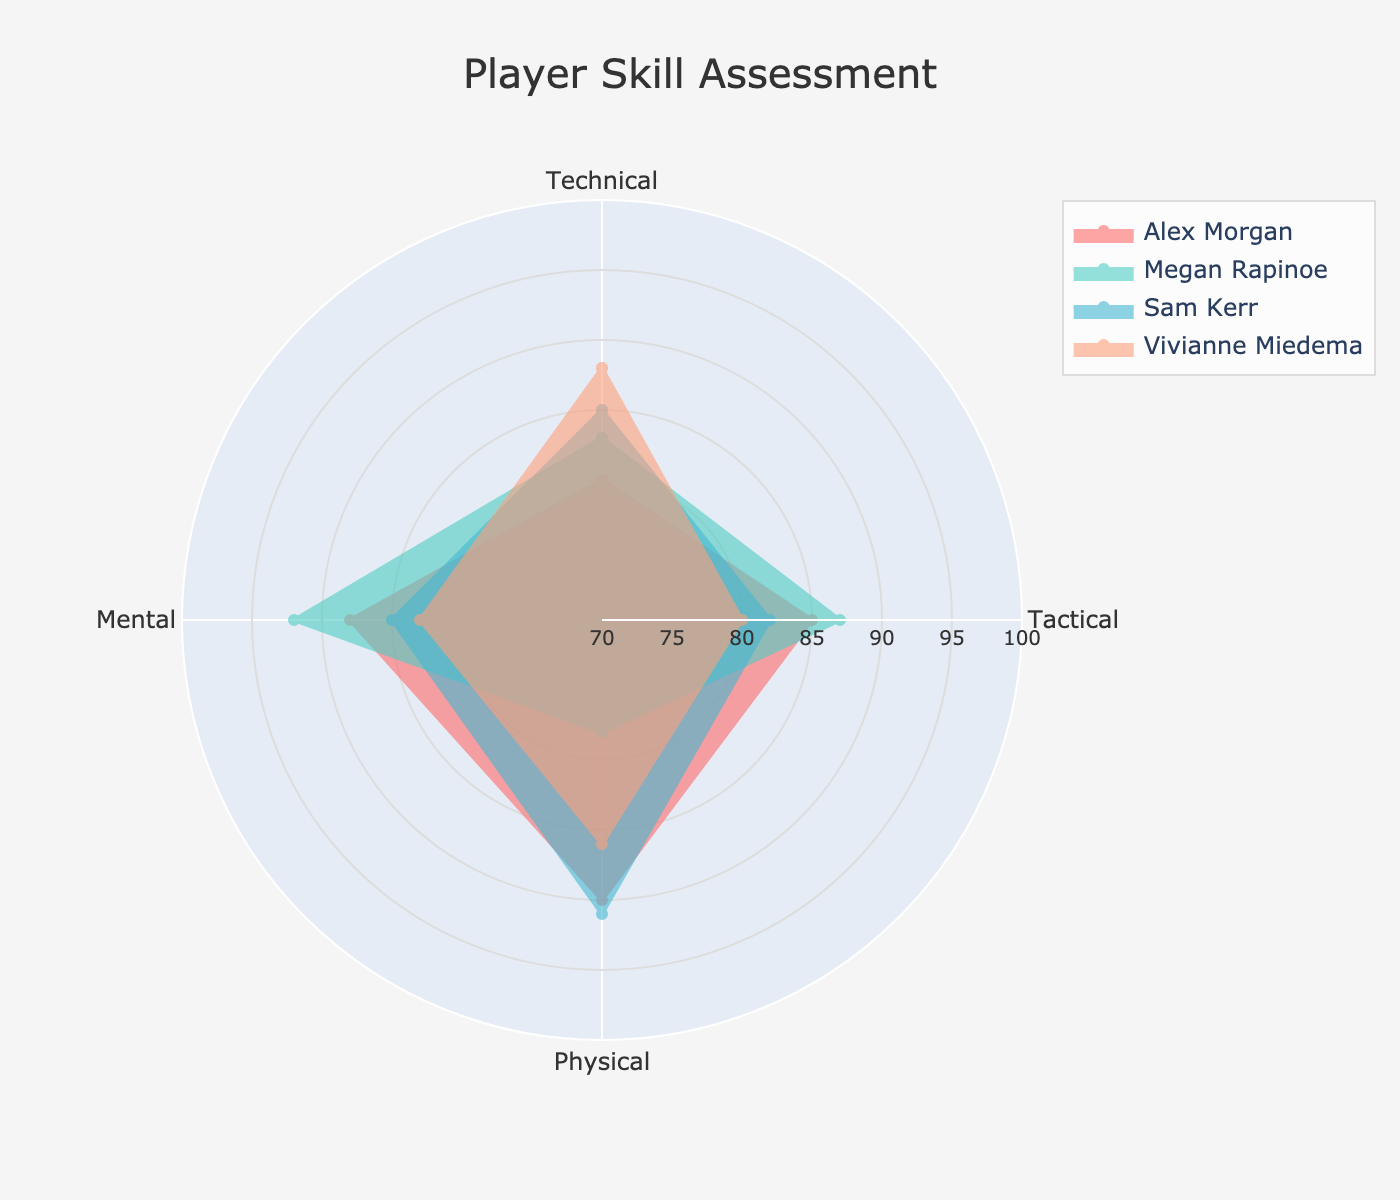What's the title of the radar chart? Look at the top of the chart where the title is usually placed. The title should describe the content of the radar chart.
Answer: Player Skill Assessment Which player has the highest Technical score? Compare the Technical scores of all players listed around the radar chart's axes. The player associated with the highest value is the one with the highest Technical score.
Answer: Vivianne Miedema Who has the lowest Physical score? Inspect each player's Physical score on the radar chart. The lowest score will be the one that's closest to the center.
Answer: Megan Rapinoe Which category does Sam Kerr excel in the most? Look at the radar chart's axes corresponding to Sam Kerr's scores. Identify the highest score among Technical, Tactical, Physical, and Mental categories.
Answer: Physical Average Mental score of all players? Sum up all the Mental scores for each player (88 + 92 + 85 + 83 = 348). Then, divide by the number of players (4). 348 / 4 = 87.
Answer: 87 Which player has the most balanced skill set across categories? A balanced skill set would mean similar lengths of the axes radiating from the center for one player. Compare the shapes of the radar plots for all players to see which one is closest to a round shape.
Answer: Vivianne Miedema Who has the highest combined total score of all categories? Sum the scores for Technical, Tactical, Physical, and Mental for each player. Alex Morgan: 343, Megan Rapinoe: 340, Sam Kerr: 343, Vivianne Miedema: 337. Compare totals to find the highest.
Answer: Alex Morgan and Sam Kerr Which player has the most disparity between their highest and lowest scores? Calculate the difference between the highest and lowest scores for each player. Compare the differences to find the largest one.
Answer: Megan Rapinoe If the total score range was adjusted to 0-100, which player would have the highest average score across all categories? Calculate the average score for each player if the scores are normalized (though they're already in 0-100, we take raw averages here). For each player, sum the scores and divide by 4. Compare the averages: Alex Morgan (85.75), Megan Rapinoe (85), Sam Kerr (85.75), Vivianne Miedema (84.25). The ones with the highest average are Alex Morgan and Sam Kerr.
Answer: Alex Morgan and Sam Kerr Given the same total score, do Alex Morgan and Sam Kerr have the same proficiency across each category? Examine and compare the detailed scores in each category for Alex Morgan and Sam Kerr. Alex Morgan: Technical (80), Tactical (85), Physical (90), Mental (88). Sam Kerr: Technical (85), Tactical (82), Physical (91), Mental (85). The individual scores differ.
Answer: No 